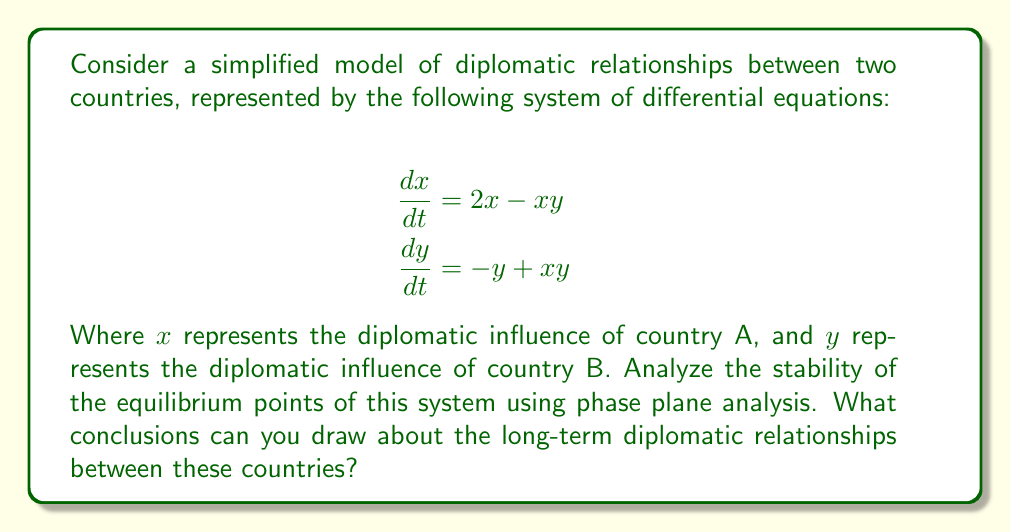What is the answer to this math problem? To analyze the stability of the diplomatic relationships, we'll follow these steps:

1) Find the equilibrium points:
   Set $\frac{dx}{dt} = 0$ and $\frac{dy}{dt} = 0$:
   
   $$\begin{aligned}
   2x - xy &= 0 \\
   -y + xy &= 0
   \end{aligned}$$

   Solving these equations, we get two equilibrium points:
   $(0, 0)$ and $(1, 2)$

2) Linearize the system around each equilibrium point:
   The Jacobian matrix is:
   
   $$J = \begin{bmatrix}
   2-y & -x \\
   y & x-1
   \end{bmatrix}$$

3) Evaluate the Jacobian at each equilibrium point:

   At $(0, 0)$:
   $$J_{(0,0)} = \begin{bmatrix}
   2 & 0 \\
   0 & -1
   \end{bmatrix}$$

   At $(1, 2)$:
   $$J_{(1,2)} = \begin{bmatrix}
   0 & -1 \\
   2 & 0
   \end{bmatrix}$$

4) Find the eigenvalues of each Jacobian:

   For $J_{(0,0)}$:
   $\lambda_1 = 2$, $\lambda_2 = -1$

   For $J_{(1,2)}$:
   $\lambda_{1,2} = \pm \sqrt{2}i$

5) Classify the equilibrium points:

   $(0, 0)$: Saddle point (unstable)
   $(1, 2)$: Center (neutrally stable)

6) Interpret the results:

   The origin $(0, 0)$ represents a state where neither country has diplomatic influence. This state is unstable, suggesting that some level of diplomatic influence will always exist.

   The point $(1, 2)$ represents a state of balanced diplomatic influence. The center nature of this point suggests that the diplomatic relationship will oscillate around this balance without converging or diverging.

[asy]
import graph;
size(200);
xaxis("x", -0.5, 3, Arrow);
yaxis("y", -0.5, 3, Arrow);

void drawVector(real x, real y, real dx, real dy) {
  draw((x,y)--(x+0.2*dx,y+0.2*dy), Arrow);
}

for(real x = 0; x <= 2.5; x += 0.5)
  for(real y = 0; y <= 2.5; y += 0.5)
    drawVector(x, y, 2*x - x*y, -y + x*y);

dot((0,0));
dot((1,2));
label("(0,0)", (0,0), SW);
label("(1,2)", (1,2), NE);
[/asy]
Answer: The system has two equilibrium points: an unstable saddle point at (0,0) and a neutrally stable center at (1,2), indicating oscillating diplomatic relationships around a balanced state. 